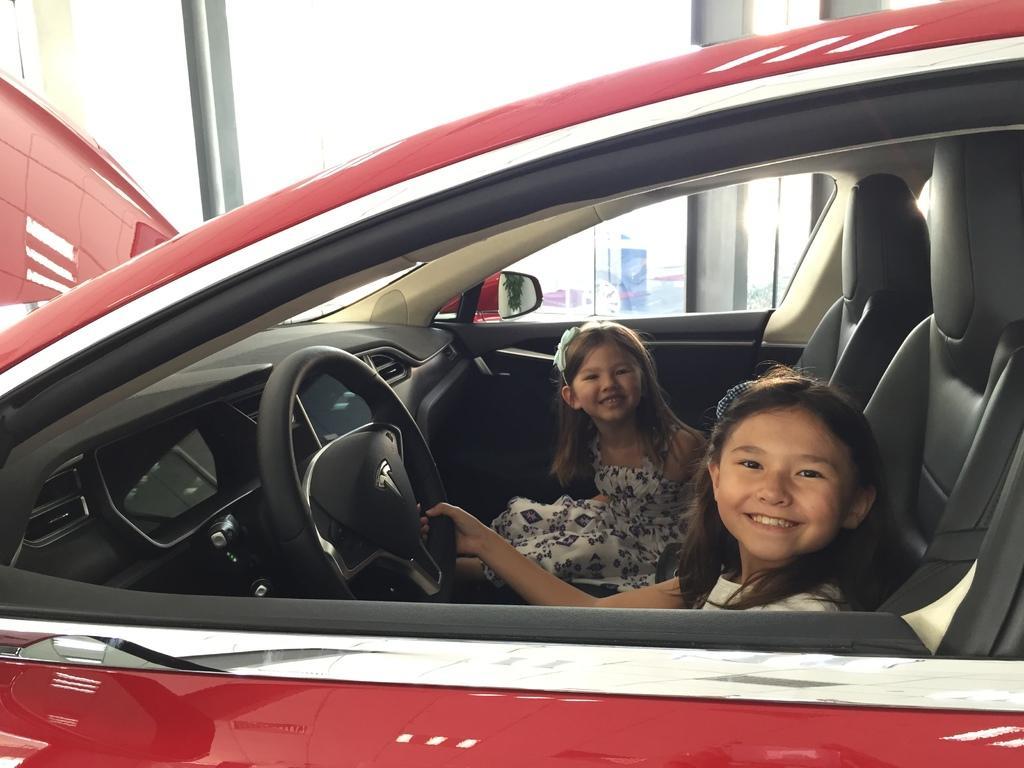Can you describe this image briefly? The two persons are sitting on a car seats. On the right side we have a girl. She is holding a steering. We can see in background banner,sky. 